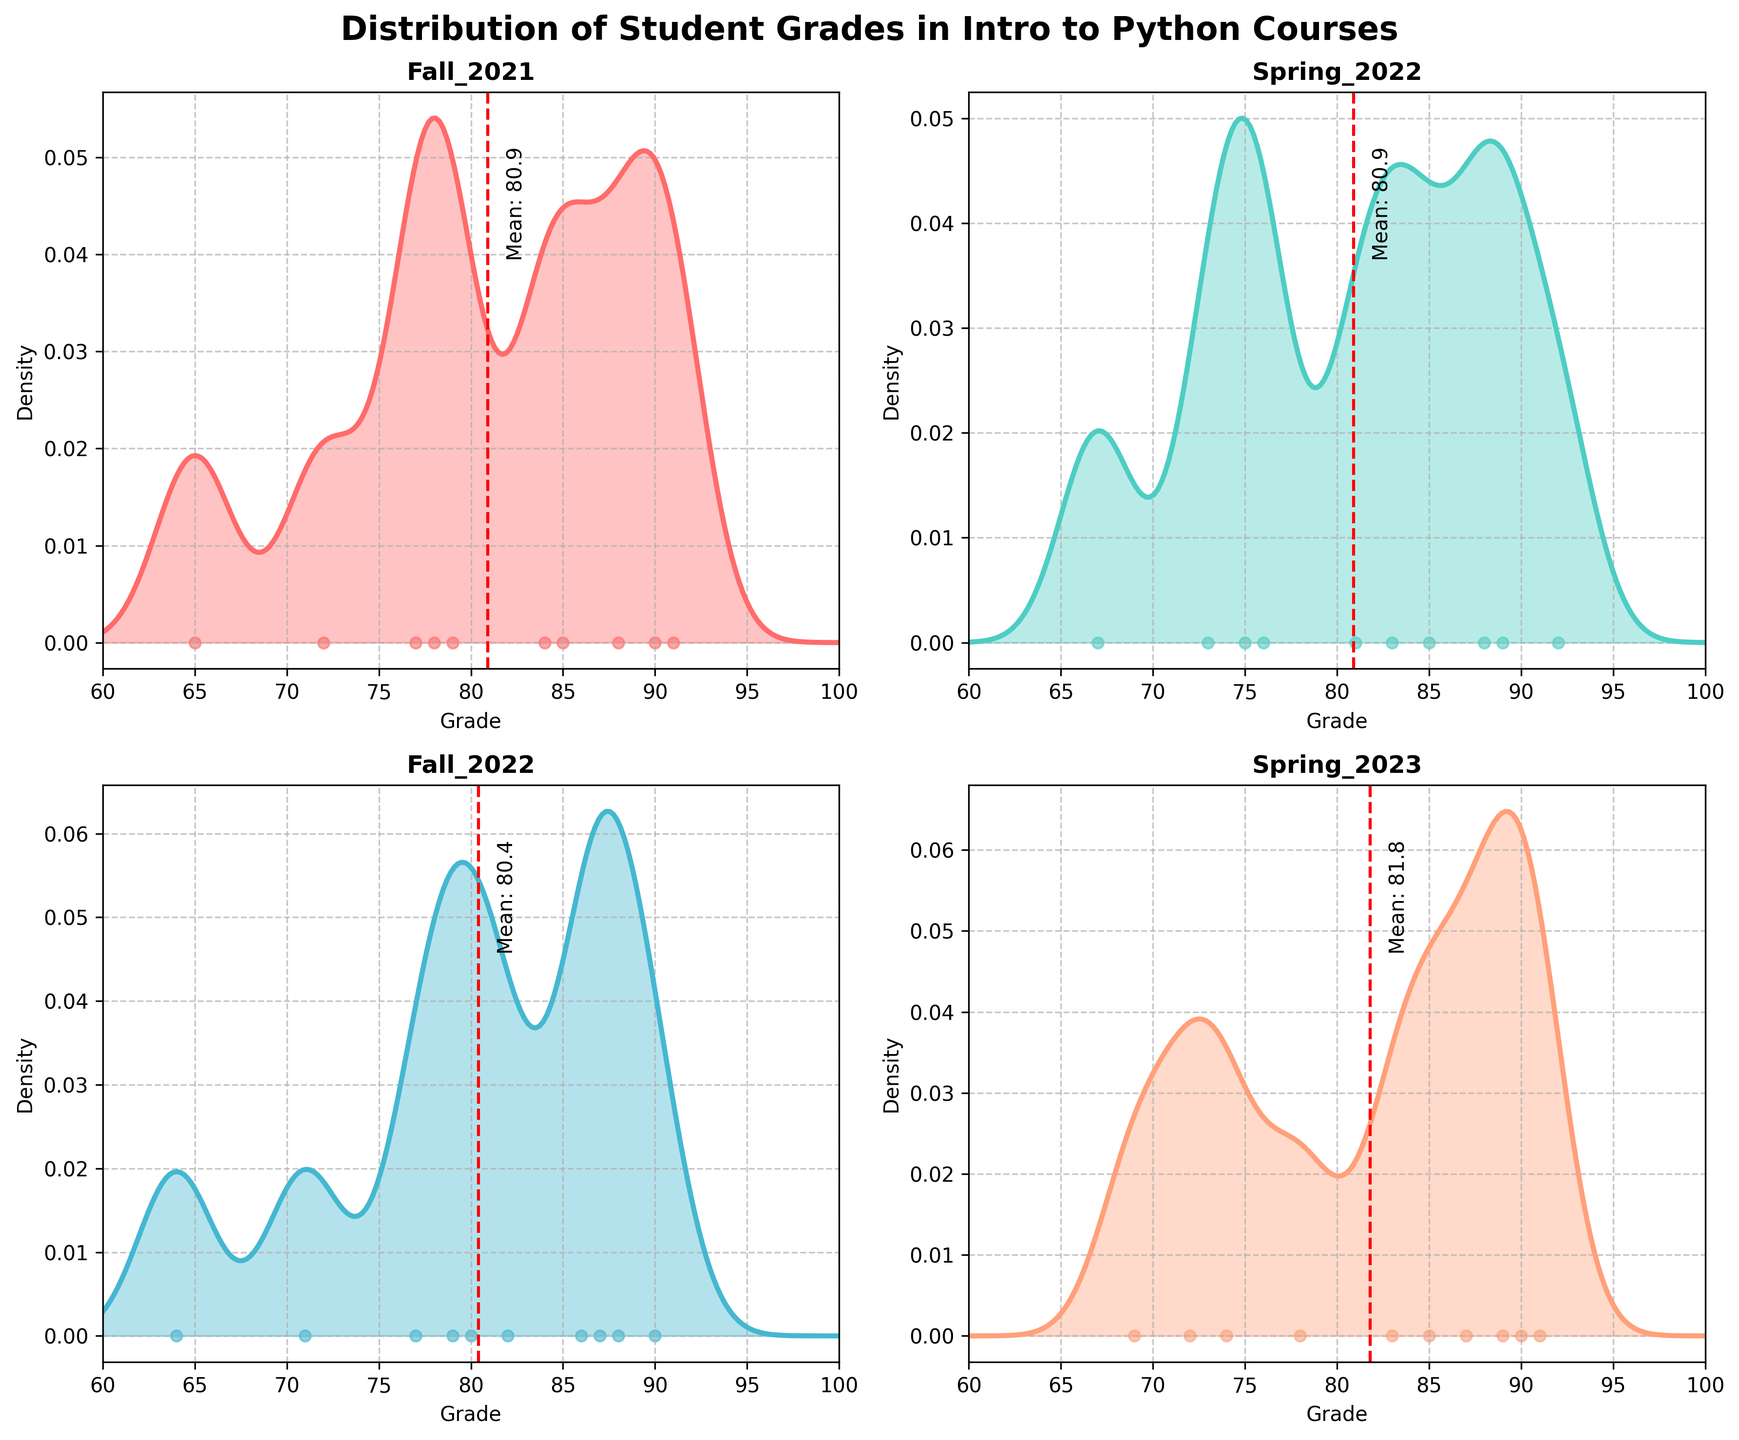What's the title of the figure? The title of the figure is displayed at the top in bold and larger font.
Answer: Distribution of Student Grades in Intro to Python Courses How many subplots are there in the figure? The figure has a 2x2 grid layout, meaning there are 4 subplots.
Answer: 4 Which semester has the highest mean grade? By observing the red dashed lines in each subplot, which indicate the mean grade, the highest mean can be identified.
Answer: Spring_2023 What color represents the Fall_2021 semester? The color palette of the subplots uses distinct colors for each semester. The Fall_2021 subplot is the first one.
Answer: Red (#FF6B6B) How does the grade distribution in Fall_2021 compare to Fall_2022? The density plot and scatter points can be compared visually. Fall_2021 has more spread and lower peak, while Fall_2022 is more concentrated around 80-90.
Answer: Fall_2021 is more spread out, Fall_2022 is more concentrated Which semester shows the most uniform grade distribution? The semester with the flattest density curve indicates the most uniform distribution.
Answer: Spring_2022 What are the x-axis and y-axis labels of each subplot? The labels are written beside the axes. The x-axis label is 'Grade' and the y-axis label is 'Density'.
Answer: Grade (x-axis), Density (y-axis) What is the approximate density value for a grade of 80 in Spring_2022? By finding the grade of 80 and following up to the density curve, the approximate value can be read.
Answer: ~0.025 How many students' grades are represented for each semester? Each subplot has 10 scatter points representing individual grades.
Answer: 10 for each semester Which semester's subplot shows a mean grade closest to 85? By looking at the position of the red dashed line for the mean and checking the text labels, the nearest to 85 is identified.
Answer: Spring_2022 